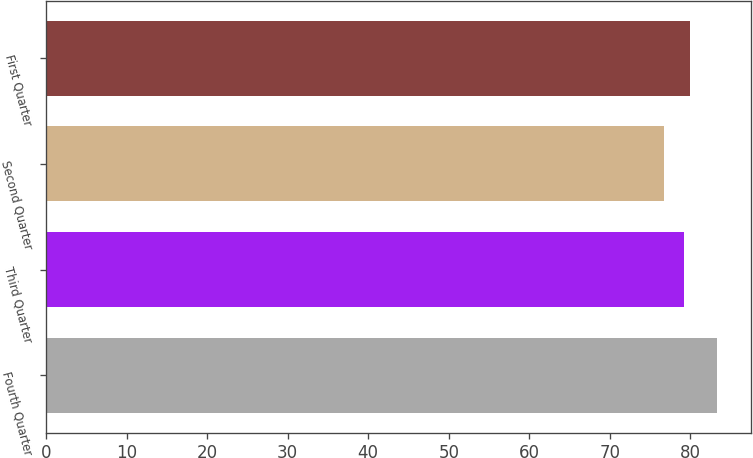Convert chart. <chart><loc_0><loc_0><loc_500><loc_500><bar_chart><fcel>Fourth Quarter<fcel>Third Quarter<fcel>Second Quarter<fcel>First Quarter<nl><fcel>83.33<fcel>79.23<fcel>76.75<fcel>79.89<nl></chart> 